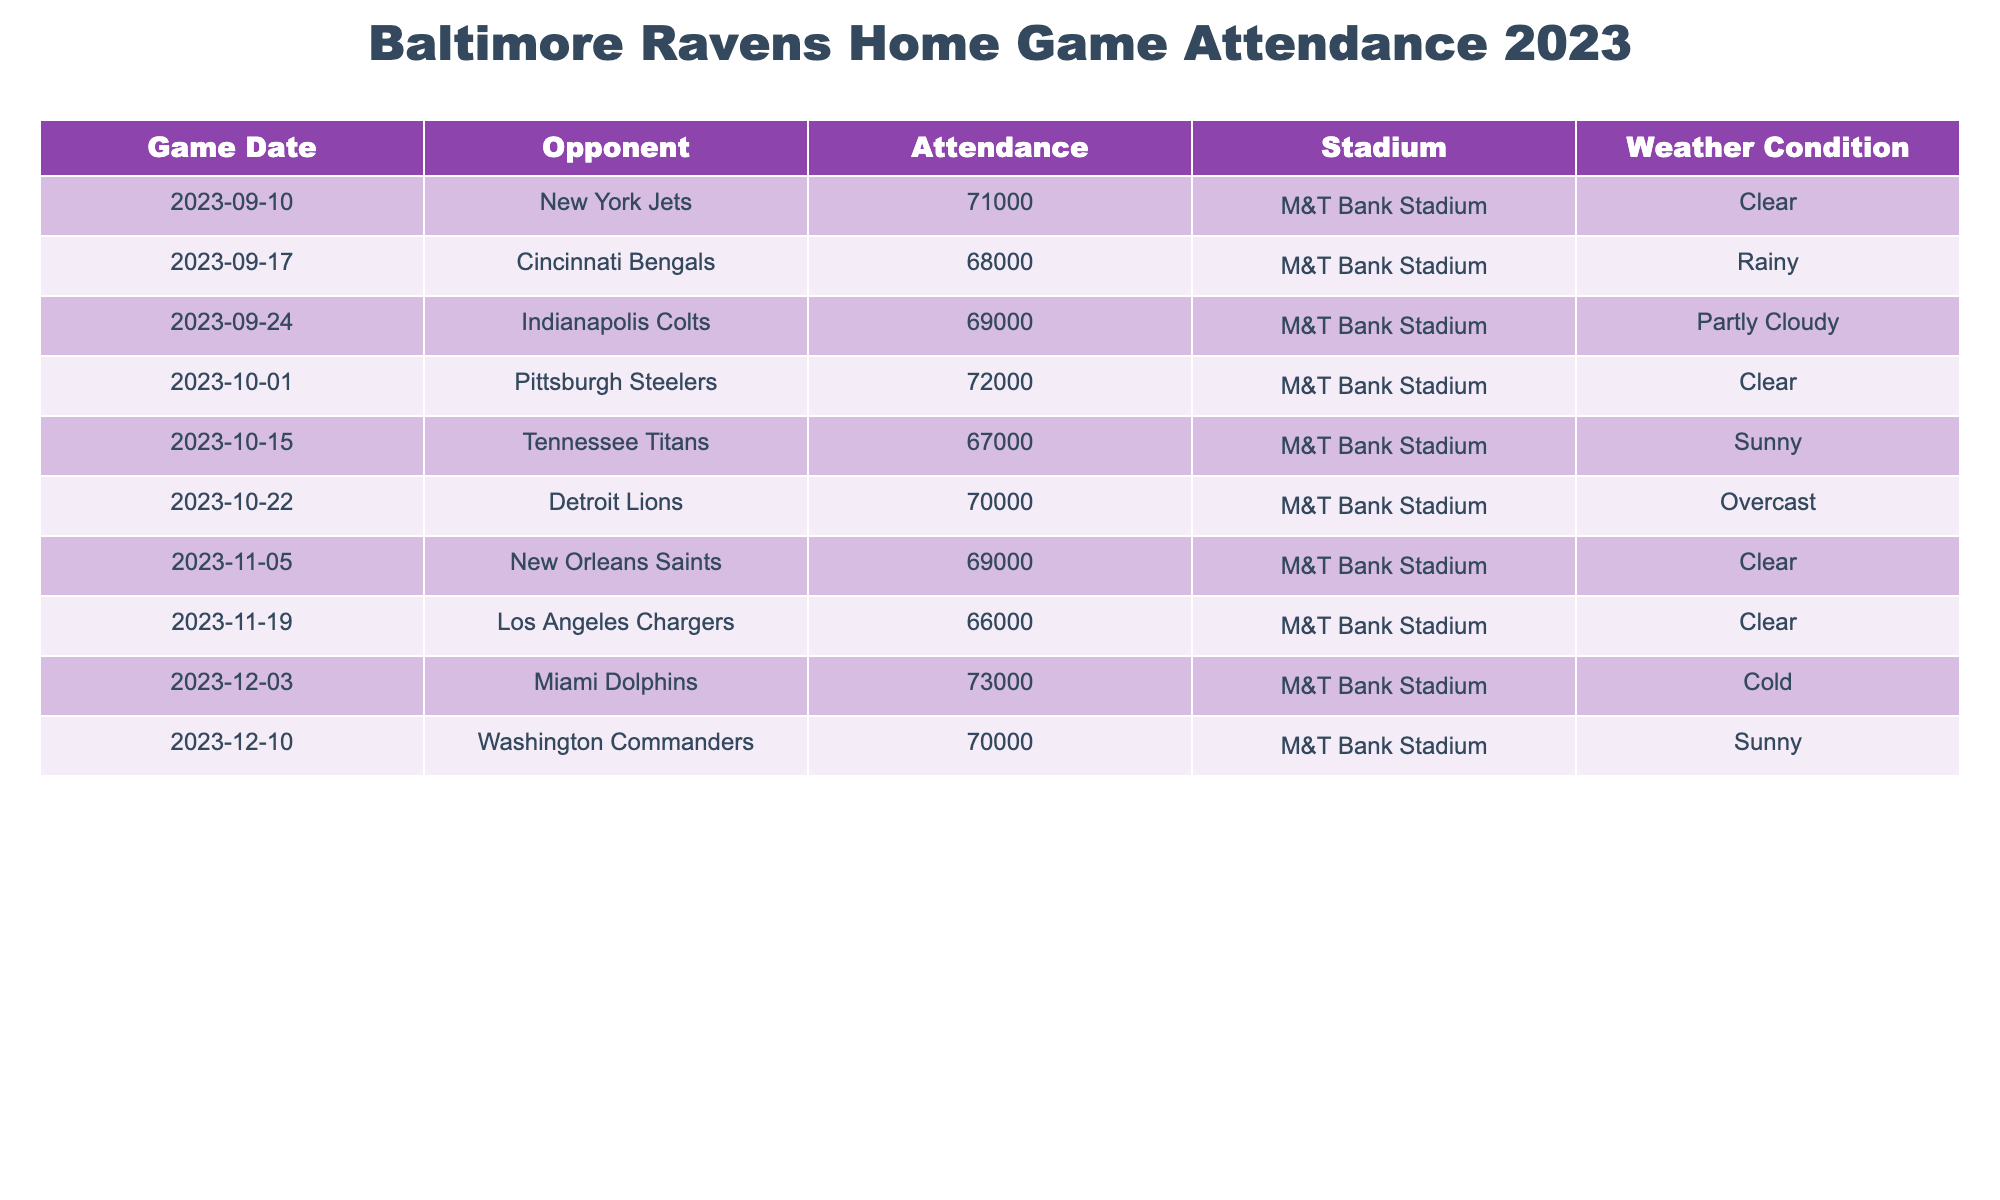What was the attendance for the game against the Pittsburgh Steelers? The second column in the table indicates the opponent for each game, and looking at the row for October 1st, the attendance figure is listed as 72,000.
Answer: 72,000 How many games had an attendance figure of over 70,000? By examining the attendance figures in the table, we see the following numbers above 70,000: 71,000 (Jets), 72,000 (Steelers), 73,000 (Dolphins), leading to a total of three games.
Answer: 3 What was the total attendance for all home games in the season? To find the total attendance, we sum the attendance of all games listed: 71,000 + 68,000 + 69,000 + 72,000 + 67,000 + 70,000 + 69,000 + 66,000 + 73,000 + 70,000 =  684,000.
Answer: 684,000 Was the weather condition for the game against the Tennessee Titans sunny? Looking at the row for the Tennessee Titans on October 15, the weather condition is indeed noted as sunny.
Answer: Yes What is the difference in attendance between the highest and lowest-attended games? Upon examining the table, the highest attendance is 73,000 (Dolphins) and the lowest is 66,000 (Chargers). The difference is calculated as 73,000 - 66,000 = 7,000.
Answer: 7,000 How many games were played under clear weather conditions, and what was the attendance for those games? The games with clear weather were against the New York Jets (71,000), Pittsburgh Steelers (72,000), New Orleans Saints (69,000), and one more against Washington Commanders (70,000). There are four games total.
Answer: 4 What was the average attendance for the games held during clear weather conditions? The attendance for clear weather games are 71,000, 72,000, and 69,000, and 70,000. Summing these gives 282,000 across four games. To find the average, we divide 282,000 by 4, which equals 70,500.
Answer: 70,500 Which opponent had the lowest attendance figure? By examining the attendance figures, the game against the Los Angeles Chargers had the lowest figure, which was 66,000.
Answer: Los Angeles Chargers What is the weather condition of the game against the Detroit Lions? In the row for the game on October 22 against the Detroit Lions, the weather condition is listed as overcast.
Answer: Overcast 